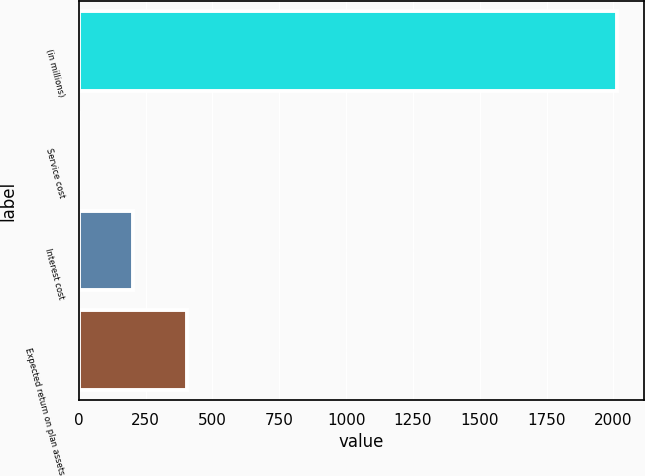<chart> <loc_0><loc_0><loc_500><loc_500><bar_chart><fcel>(in millions)<fcel>Service cost<fcel>Interest cost<fcel>Expected return on plan assets<nl><fcel>2015<fcel>2<fcel>203.3<fcel>404.6<nl></chart> 